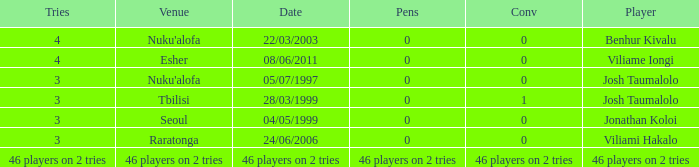What date did Josh Taumalolo play at Nuku'alofa? 05/07/1997. 